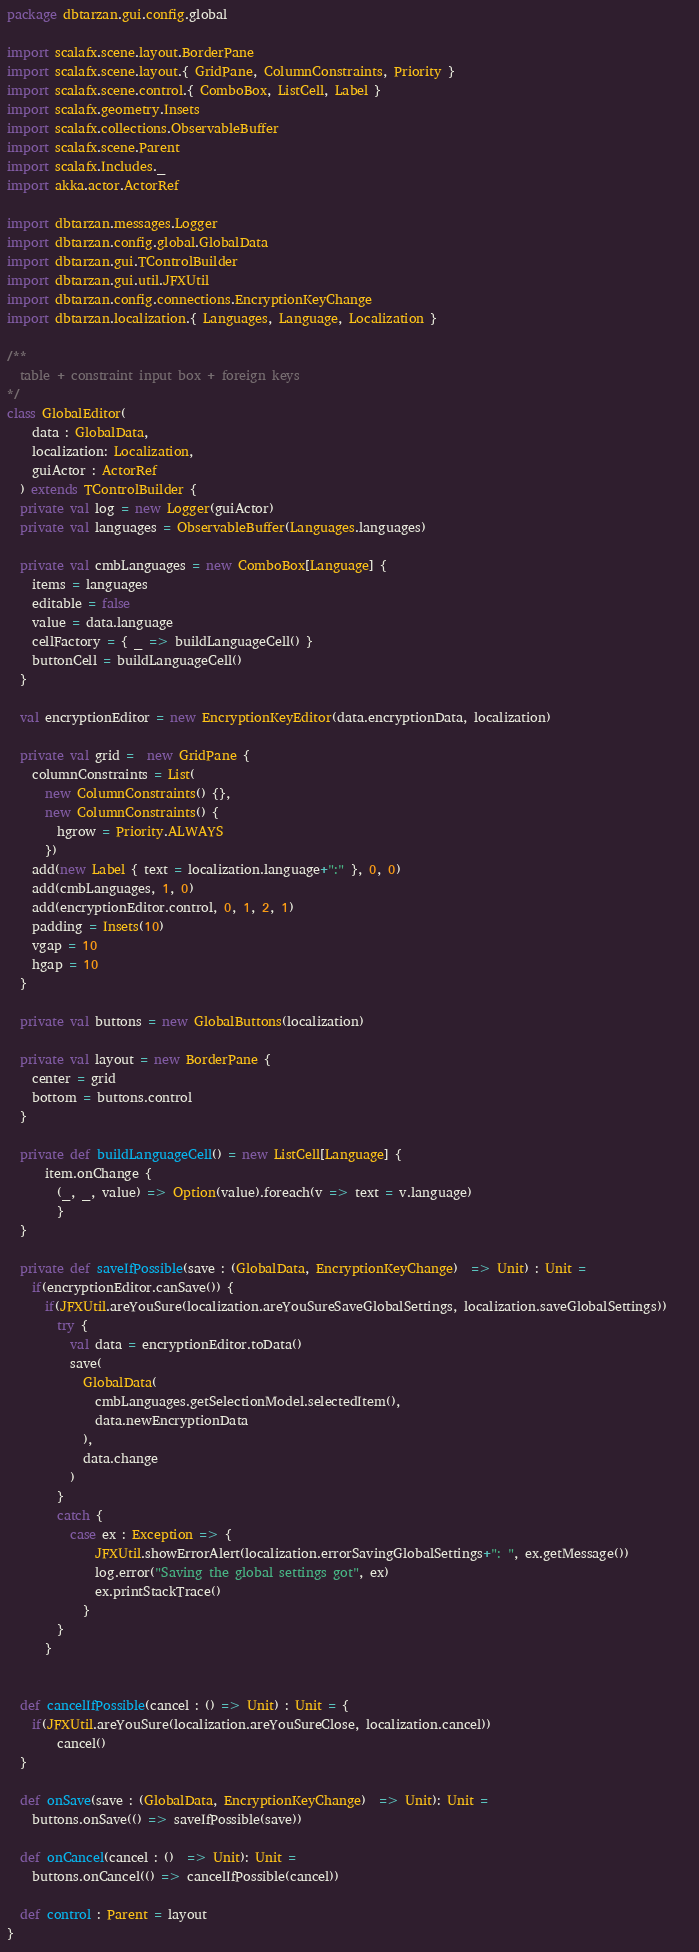Convert code to text. <code><loc_0><loc_0><loc_500><loc_500><_Scala_>package dbtarzan.gui.config.global

import scalafx.scene.layout.BorderPane
import scalafx.scene.layout.{ GridPane, ColumnConstraints, Priority }
import scalafx.scene.control.{ ComboBox, ListCell, Label }
import scalafx.geometry.Insets
import scalafx.collections.ObservableBuffer
import scalafx.scene.Parent
import scalafx.Includes._
import akka.actor.ActorRef

import dbtarzan.messages.Logger
import dbtarzan.config.global.GlobalData
import dbtarzan.gui.TControlBuilder
import dbtarzan.gui.util.JFXUtil
import dbtarzan.config.connections.EncryptionKeyChange
import dbtarzan.localization.{ Languages, Language, Localization }

/**
  table + constraint input box + foreign keys
*/
class GlobalEditor(
    data : GlobalData,
    localization: Localization,
    guiActor : ActorRef
  ) extends TControlBuilder {
  private val log = new Logger(guiActor)
  private val languages = ObservableBuffer(Languages.languages)

  private val cmbLanguages = new ComboBox[Language] {
    items = languages
    editable = false
    value = data.language
    cellFactory = { _ => buildLanguageCell() }
    buttonCell = buildLanguageCell()
  }

  val encryptionEditor = new EncryptionKeyEditor(data.encryptionData, localization)

  private val grid =  new GridPane {
    columnConstraints = List(
      new ColumnConstraints() {},
      new ColumnConstraints() {
        hgrow = Priority.ALWAYS
      })
    add(new Label { text = localization.language+":" }, 0, 0)
    add(cmbLanguages, 1, 0)
    add(encryptionEditor.control, 0, 1, 2, 1)
    padding = Insets(10)
    vgap = 10
    hgap = 10
  }

  private val buttons = new GlobalButtons(localization) 

  private val layout = new BorderPane {
    center = grid
    bottom = buttons.control
  }

  private def buildLanguageCell() = new ListCell[Language] {
      item.onChange { 
        (_, _, value) => Option(value).foreach(v => text = v.language)
        }
  }
  
  private def saveIfPossible(save : (GlobalData, EncryptionKeyChange)  => Unit) : Unit = 
    if(encryptionEditor.canSave()) {
      if(JFXUtil.areYouSure(localization.areYouSureSaveGlobalSettings, localization.saveGlobalSettings))    
        try { 
          val data = encryptionEditor.toData()
          save(
            GlobalData(
              cmbLanguages.getSelectionModel.selectedItem(),
              data.newEncryptionData
            ),
            data.change
          ) 
        } 
        catch {
          case ex : Exception => {
              JFXUtil.showErrorAlert(localization.errorSavingGlobalSettings+": ", ex.getMessage())
              log.error("Saving the global settings got", ex)
              ex.printStackTrace()
            }
        }
      }
  

  def cancelIfPossible(cancel : () => Unit) : Unit = {
    if(JFXUtil.areYouSure(localization.areYouSureClose, localization.cancel))
        cancel()
  }

  def onSave(save : (GlobalData, EncryptionKeyChange)  => Unit): Unit =
    buttons.onSave(() => saveIfPossible(save))

  def onCancel(cancel : ()  => Unit): Unit =
    buttons.onCancel(() => cancelIfPossible(cancel))

  def control : Parent = layout
}</code> 